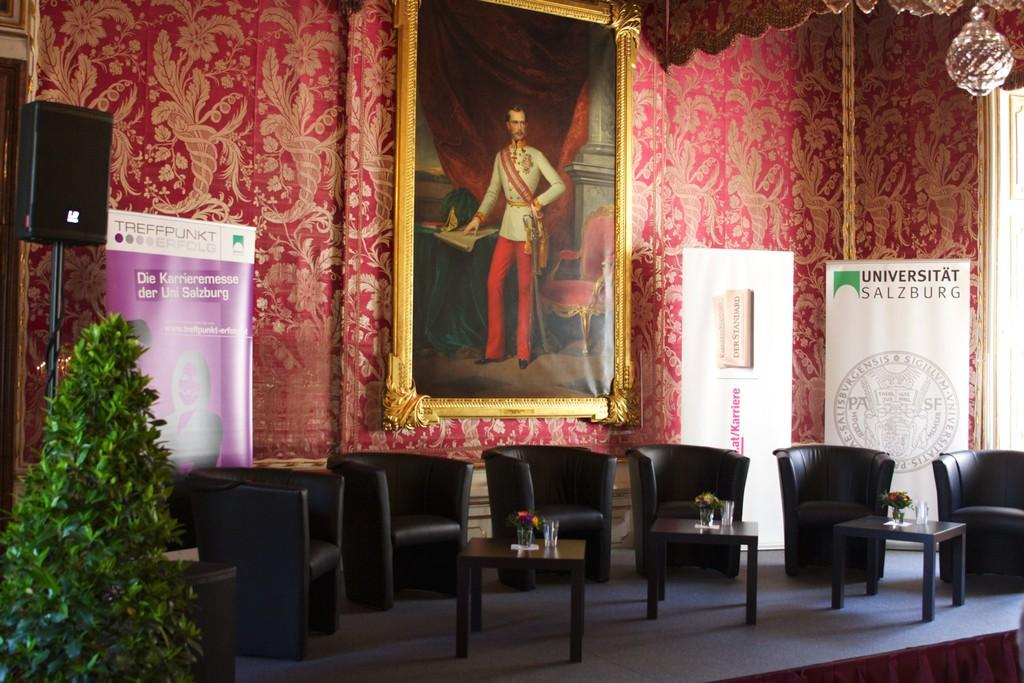How many chairs are visible in the image? There are 6 chairs in the image. How many tables are present in the image? There are 3 tables in the image. What can be found on the tables? There are glasses on the tables. What type of vegetation is present in the image? There is a plant in the image. What can be seen in the background of the image? There is a speaker and 3 yards in the background. What is hanging on the wall in the background? There is a photo frame on the wall in the background. Can you see the person in the image attempting to smile with their hand? There is no person present in the image, and therefore no attempt to smile with their hand can be observed. 